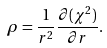Convert formula to latex. <formula><loc_0><loc_0><loc_500><loc_500>\rho = \frac { 1 } { r ^ { 2 } } \frac { \partial ( \chi ^ { 2 } ) } { \partial r } .</formula> 